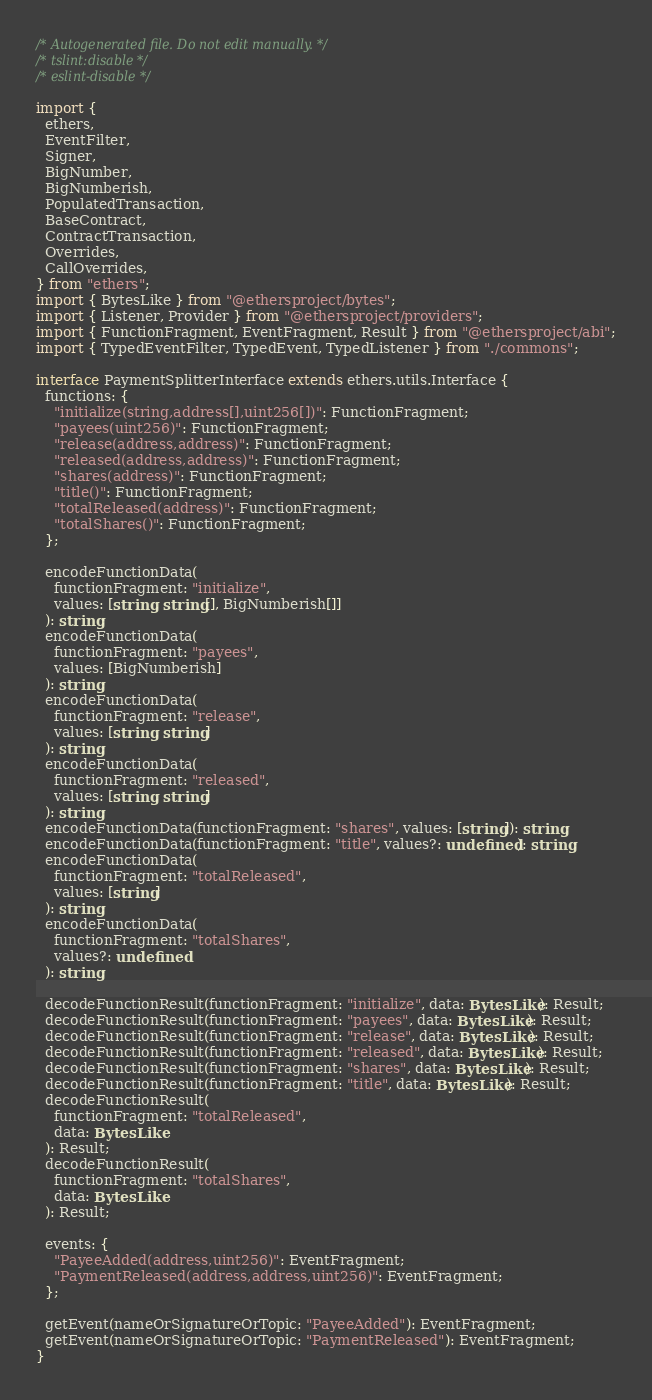<code> <loc_0><loc_0><loc_500><loc_500><_TypeScript_>/* Autogenerated file. Do not edit manually. */
/* tslint:disable */
/* eslint-disable */

import {
  ethers,
  EventFilter,
  Signer,
  BigNumber,
  BigNumberish,
  PopulatedTransaction,
  BaseContract,
  ContractTransaction,
  Overrides,
  CallOverrides,
} from "ethers";
import { BytesLike } from "@ethersproject/bytes";
import { Listener, Provider } from "@ethersproject/providers";
import { FunctionFragment, EventFragment, Result } from "@ethersproject/abi";
import { TypedEventFilter, TypedEvent, TypedListener } from "./commons";

interface PaymentSplitterInterface extends ethers.utils.Interface {
  functions: {
    "initialize(string,address[],uint256[])": FunctionFragment;
    "payees(uint256)": FunctionFragment;
    "release(address,address)": FunctionFragment;
    "released(address,address)": FunctionFragment;
    "shares(address)": FunctionFragment;
    "title()": FunctionFragment;
    "totalReleased(address)": FunctionFragment;
    "totalShares()": FunctionFragment;
  };

  encodeFunctionData(
    functionFragment: "initialize",
    values: [string, string[], BigNumberish[]]
  ): string;
  encodeFunctionData(
    functionFragment: "payees",
    values: [BigNumberish]
  ): string;
  encodeFunctionData(
    functionFragment: "release",
    values: [string, string]
  ): string;
  encodeFunctionData(
    functionFragment: "released",
    values: [string, string]
  ): string;
  encodeFunctionData(functionFragment: "shares", values: [string]): string;
  encodeFunctionData(functionFragment: "title", values?: undefined): string;
  encodeFunctionData(
    functionFragment: "totalReleased",
    values: [string]
  ): string;
  encodeFunctionData(
    functionFragment: "totalShares",
    values?: undefined
  ): string;

  decodeFunctionResult(functionFragment: "initialize", data: BytesLike): Result;
  decodeFunctionResult(functionFragment: "payees", data: BytesLike): Result;
  decodeFunctionResult(functionFragment: "release", data: BytesLike): Result;
  decodeFunctionResult(functionFragment: "released", data: BytesLike): Result;
  decodeFunctionResult(functionFragment: "shares", data: BytesLike): Result;
  decodeFunctionResult(functionFragment: "title", data: BytesLike): Result;
  decodeFunctionResult(
    functionFragment: "totalReleased",
    data: BytesLike
  ): Result;
  decodeFunctionResult(
    functionFragment: "totalShares",
    data: BytesLike
  ): Result;

  events: {
    "PayeeAdded(address,uint256)": EventFragment;
    "PaymentReleased(address,address,uint256)": EventFragment;
  };

  getEvent(nameOrSignatureOrTopic: "PayeeAdded"): EventFragment;
  getEvent(nameOrSignatureOrTopic: "PaymentReleased"): EventFragment;
}
</code> 